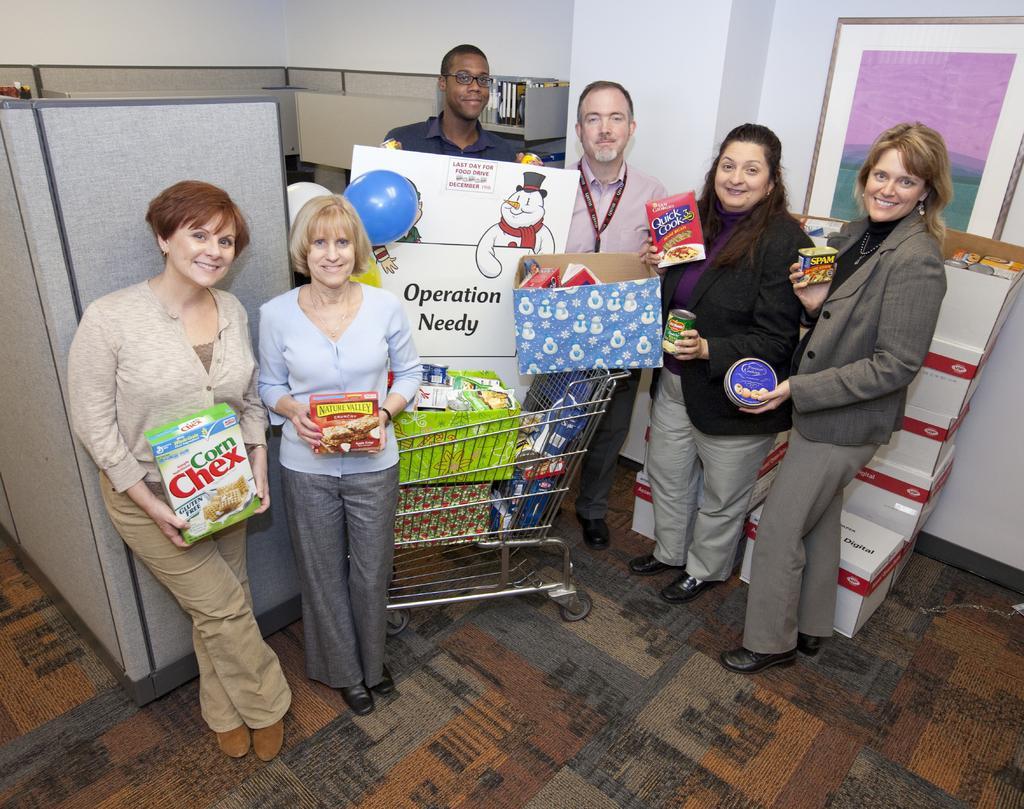Can you describe this image briefly? In this image I can see few people standing in a room and holding few objects. There is a trolley in which there are few items and a carton. It looks like a refrigerator on the left and there are cartons and a photo frame on the right. 